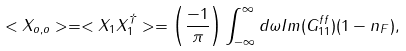Convert formula to latex. <formula><loc_0><loc_0><loc_500><loc_500>< X _ { o , o } > = < X _ { 1 } X _ { 1 } ^ { \dagger } > = \left ( \frac { - 1 } { \pi } \right ) \int _ { - \infty } ^ { \infty } d \omega I m ( G _ { 1 1 } ^ { f f } ) ( 1 - n _ { F } ) ,</formula> 